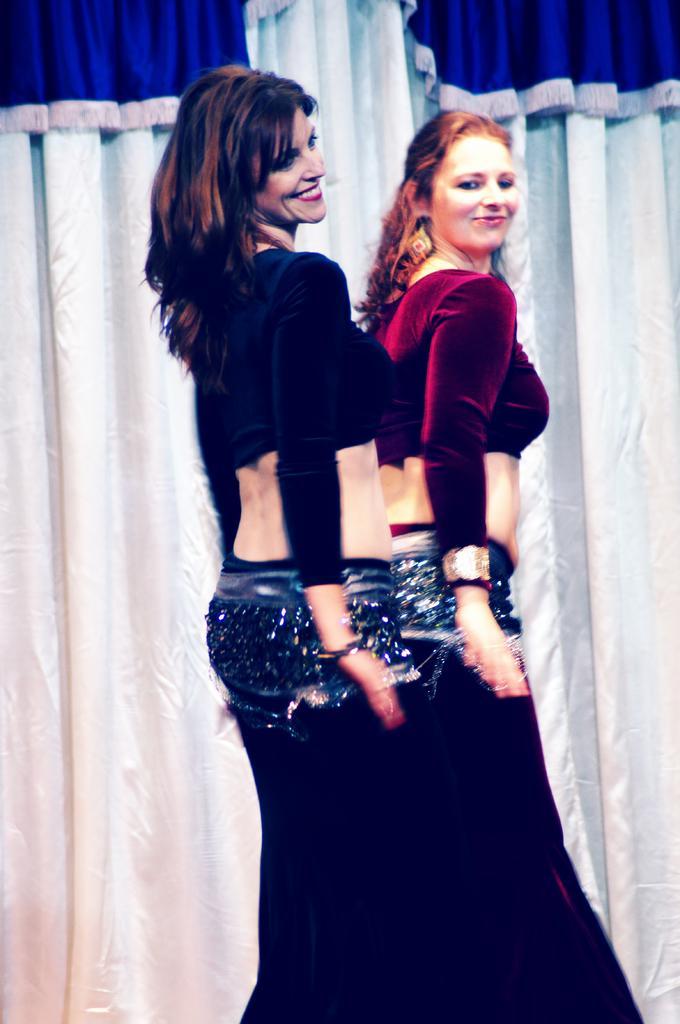Describe this image in one or two sentences. In the foreground of this image, there are two women doing belly dance. In the background, there is a white and blue curtain. 